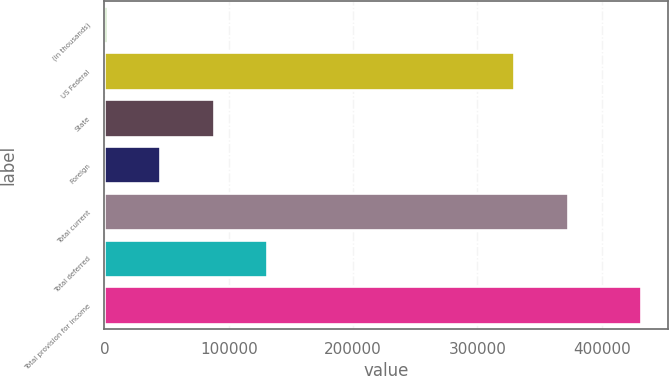<chart> <loc_0><loc_0><loc_500><loc_500><bar_chart><fcel>(in thousands)<fcel>US Federal<fcel>State<fcel>Foreign<fcel>Total current<fcel>Total deferred<fcel>Total provision for income<nl><fcel>2017<fcel>329707<fcel>87922<fcel>44969.5<fcel>372660<fcel>130874<fcel>431542<nl></chart> 